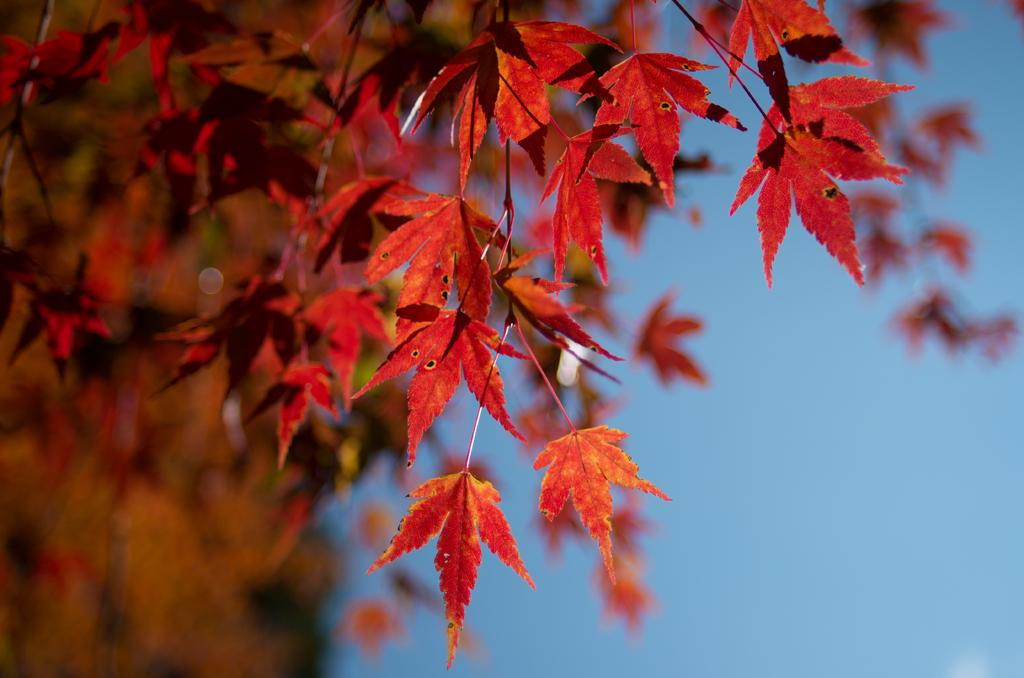What color are the leaves in the image? The leaves in the image are red. What else can be seen in the image besides the leaves? The sky is visible in the image. Is there a volcano erupting in the image? No, there is no volcano present in the image. 